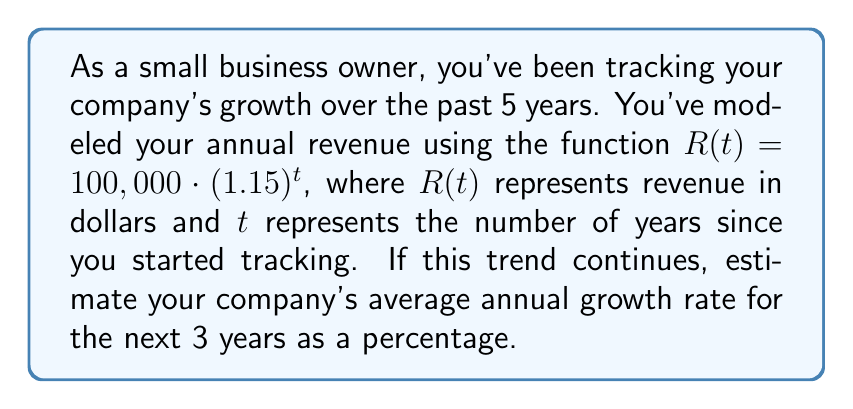What is the answer to this math problem? Let's approach this step-by-step:

1) The given function is an exponential growth model:
   $R(t) = 100,000 \cdot (1.15)^t$

2) To find the average annual growth rate, we need to calculate the total growth over 3 years and then find the average.

3) Let's calculate the revenue at $t=5$ (current) and $t=8$ (3 years from now):

   At $t=5$: $R(5) = 100,000 \cdot (1.15)^5 = 201,136.43$
   At $t=8$: $R(8) = 100,000 \cdot (1.15)^8 = 305,687.44$

4) The total growth factor over 3 years is:
   $\frac{R(8)}{R(5)} = \frac{305,687.44}{201,136.43} = 1.5198$

5) To find the average annual growth factor, we take the cube root:
   $\sqrt[3]{1.5198} = 1.1499$

6) To convert this to a percentage growth rate, we subtract 1 and multiply by 100:
   $(1.1499 - 1) \cdot 100 = 14.99\%$

Therefore, the estimated average annual growth rate for the next 3 years is approximately 14.99%.
Answer: 14.99% 